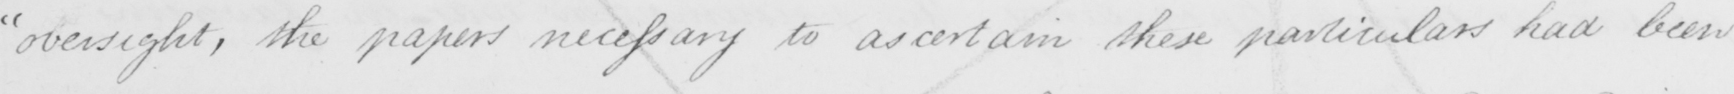What text is written in this handwritten line? " oversight , the papers necessary to ascertain these particulars had been 